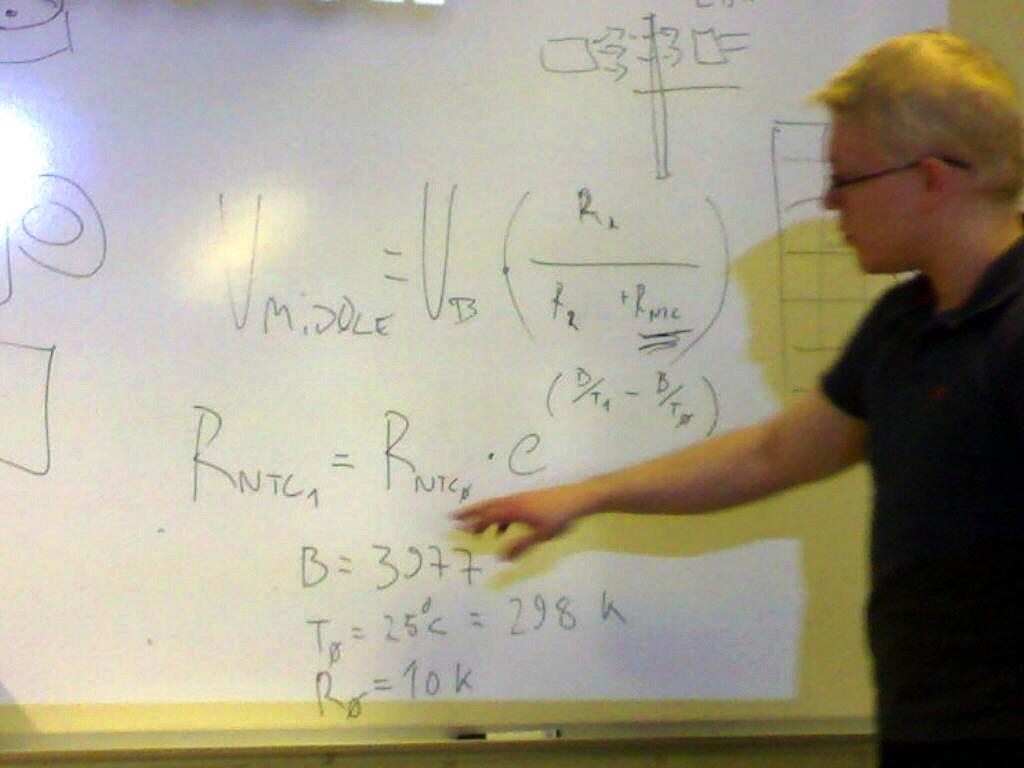What number does the variable b equal?
Provide a succinct answer. 3277. Rntc = what?
Keep it short and to the point. Rntc. 